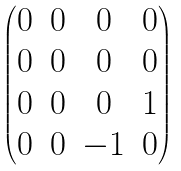<formula> <loc_0><loc_0><loc_500><loc_500>\begin{pmatrix} 0 & 0 & 0 & 0 \\ 0 & 0 & 0 & 0 \\ 0 & 0 & 0 & 1 \\ 0 & 0 & - 1 & 0 \\ \end{pmatrix}</formula> 